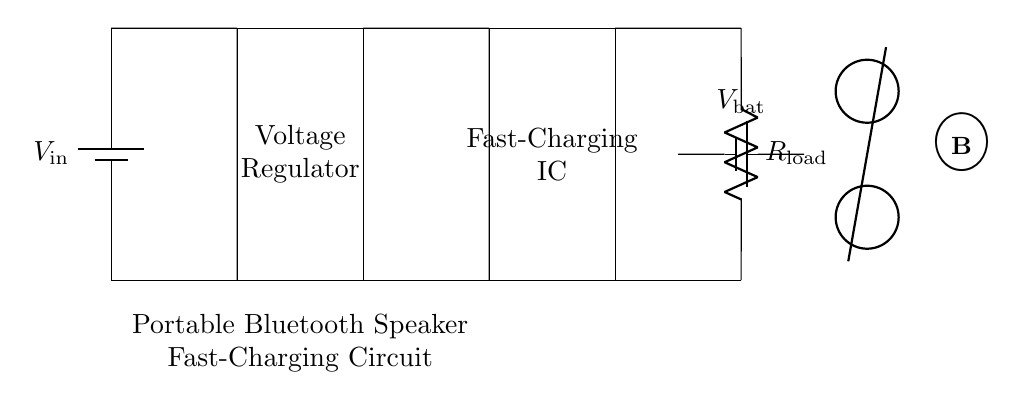What is the function of the voltage regulator in this circuit? The voltage regulator's function is to maintain a constant output voltage despite variations in input voltage or load conditions. It ensures that the Bluetooth speaker receives a stable voltage for optimal performance.
Answer: Voltage regulation What type of IC is present in this circuit? The circuit contains a fast-charging integrated circuit, which is designed to handle higher charging currents and reduce the time taken to charge the battery, thus making it suitable for quick recharges.
Answer: Fast-charging IC What does the output resistor represent? The output resistor represents the load of the portable Bluetooth speaker, which draws current from the battery during operation. It's an essential part of the circuit that emulates the actual system it would power.
Answer: Load resistor How many batteries are visible in the circuit? There are two batteries shown in the circuit diagram: one as the power source and another representing the battery of the Bluetooth speaker.
Answer: Two batteries What is the likely purpose of this circuit? The purpose of the circuit is to provide a fast and efficient charging solution for portable Bluetooth speakers, allowing users to quickly recharge their speakers during outdoor workouts or activities.
Answer: Fast charging What does the symbol next to the battery labeled V bat represent? The symbol labeled V bat represents the battery voltage of the Bluetooth speaker, indicating the voltage level that the device operates on. This is crucial for ensuring compatibility with the charging circuit.
Answer: Battery voltage Is this circuit suitable for use in outdoor workouts? Yes, the circuit is designed for portability and fast charging, making it suitable for outdoor workouts where users need quick access to power for their Bluetooth speakers.
Answer: Yes 